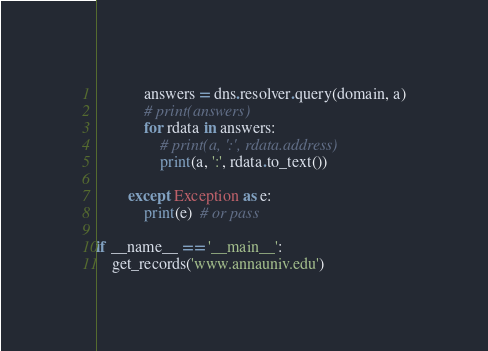<code> <loc_0><loc_0><loc_500><loc_500><_Python_>            answers = dns.resolver.query(domain, a)
            # print(answers)
            for rdata in answers:
                # print(a, ':', rdata.address)
                print(a, ':', rdata.to_text())
    
        except Exception as e:
            print(e)  # or pass

if __name__ == '__main__':
    get_records('www.annauniv.edu')
</code> 